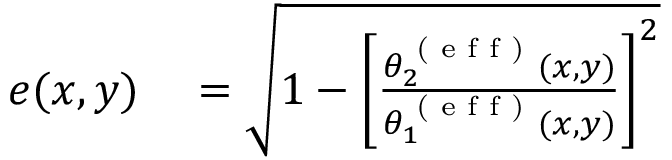Convert formula to latex. <formula><loc_0><loc_0><loc_500><loc_500>\begin{array} { r l } { e ( x , y ) } & = \sqrt { 1 - \left [ \frac { \theta _ { 2 } ^ { ( e f f ) } ( x , y ) } { \theta _ { 1 } ^ { ( e f f ) } ( x , y ) } \right ] ^ { 2 } } } \end{array}</formula> 